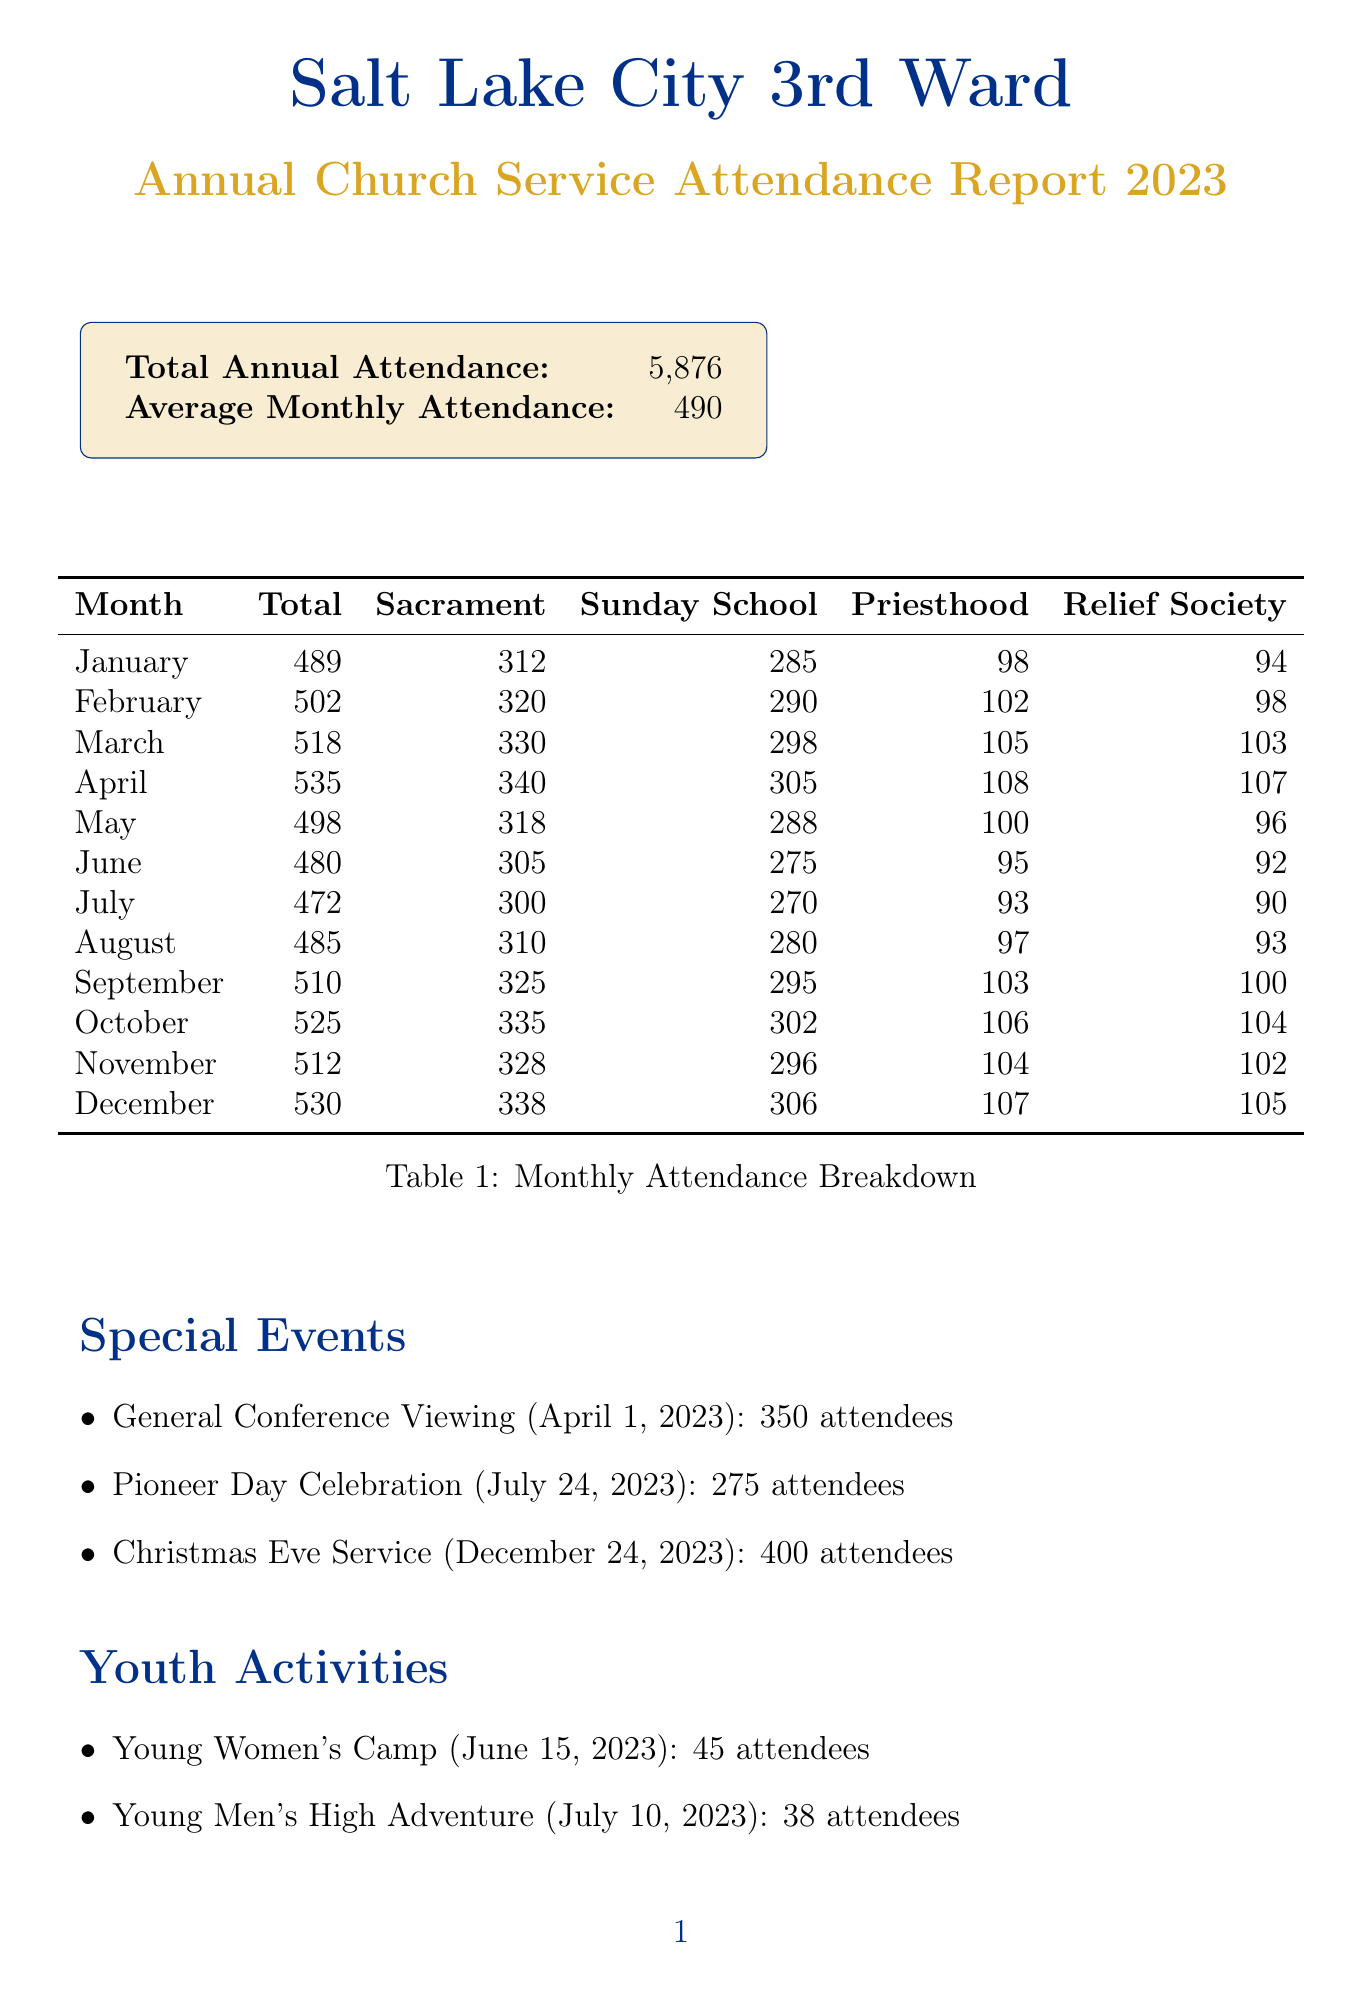What is the total annual attendance? The total annual attendance is a key metric provided in the report.
Answer: 5,876 Which month had the highest total attendance? By comparing the total attendance for each month, we find which month had the highest figure.
Answer: April How many youth activities were reported? The report lists three distinct youth activities.
Answer: 3 What was the attendance for the Christmas Eve Service? The report specifies the attendance for the Christmas Eve Service under special events.
Answer: 400 What was the average monthly temple attendance? The average monthly temple attendance is calculated from the total annual temple attendance.
Answer: 52 Which event had the lowest attendance? By reviewing the special events, we determine which had the lowest turnout.
Answer: Young Men's High Adventure What was the average attendance for Fast and Testimony meetings? This metric shows the participation level for Fast and Testimony meetings throughout the year.
Answer: 315 In which month was the General Conference Viewing held? The date of the General Conference Viewing is noted specifically in the report.
Answer: April What trend is noted regarding attendance during the summer months? The report indicates a specific observation about attendance trends in the summer.
Answer: Slight decrease 